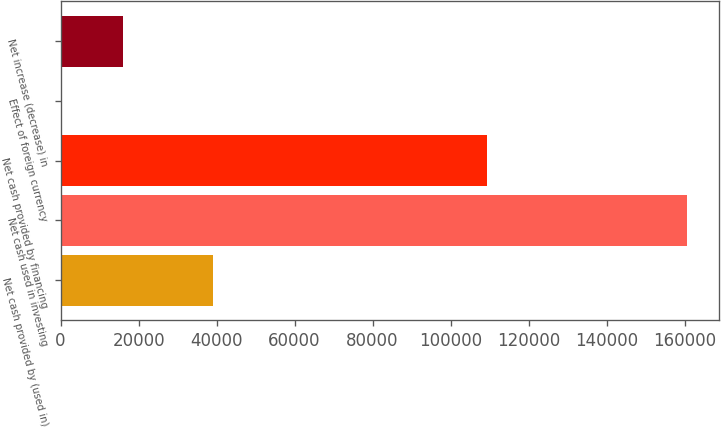Convert chart. <chart><loc_0><loc_0><loc_500><loc_500><bar_chart><fcel>Net cash provided by (used in)<fcel>Net cash used in investing<fcel>Net cash provided by financing<fcel>Effect of foreign currency<fcel>Net increase (decrease) in<nl><fcel>39000<fcel>160735<fcel>109296<fcel>3<fcel>16076.2<nl></chart> 